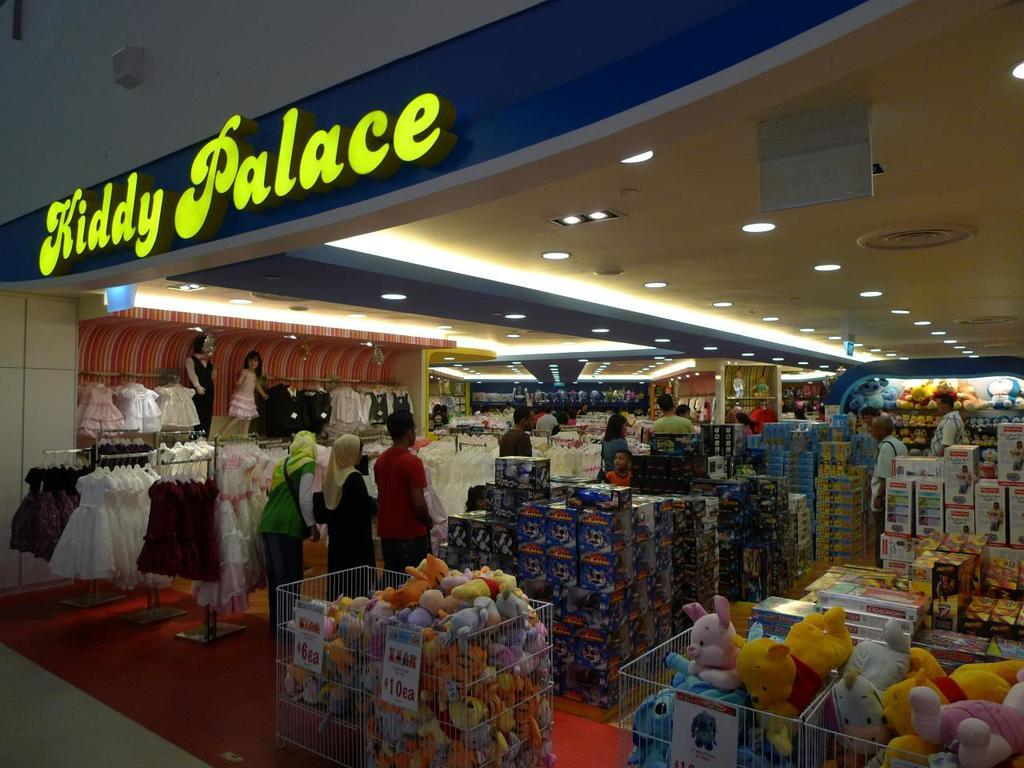<image>
Describe the image concisely. Stuffed animals at the front of the store can be purchased for 10 dollars. 